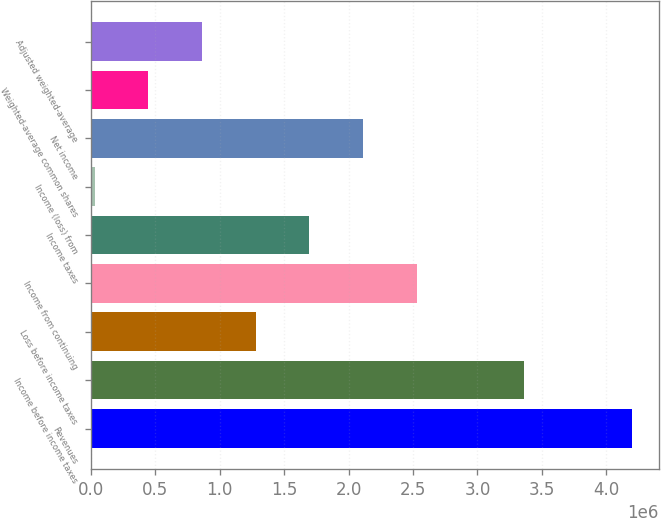<chart> <loc_0><loc_0><loc_500><loc_500><bar_chart><fcel>Revenues<fcel>Income before income taxes<fcel>Loss before income taxes<fcel>Income from continuing<fcel>Income taxes<fcel>Income (loss) from<fcel>Net income<fcel>Weighted-average common shares<fcel>Adjusted weighted-average<nl><fcel>4.19568e+06<fcel>3.36251e+06<fcel>1.27961e+06<fcel>2.52935e+06<fcel>1.69619e+06<fcel>29871<fcel>2.11277e+06<fcel>446451<fcel>863032<nl></chart> 